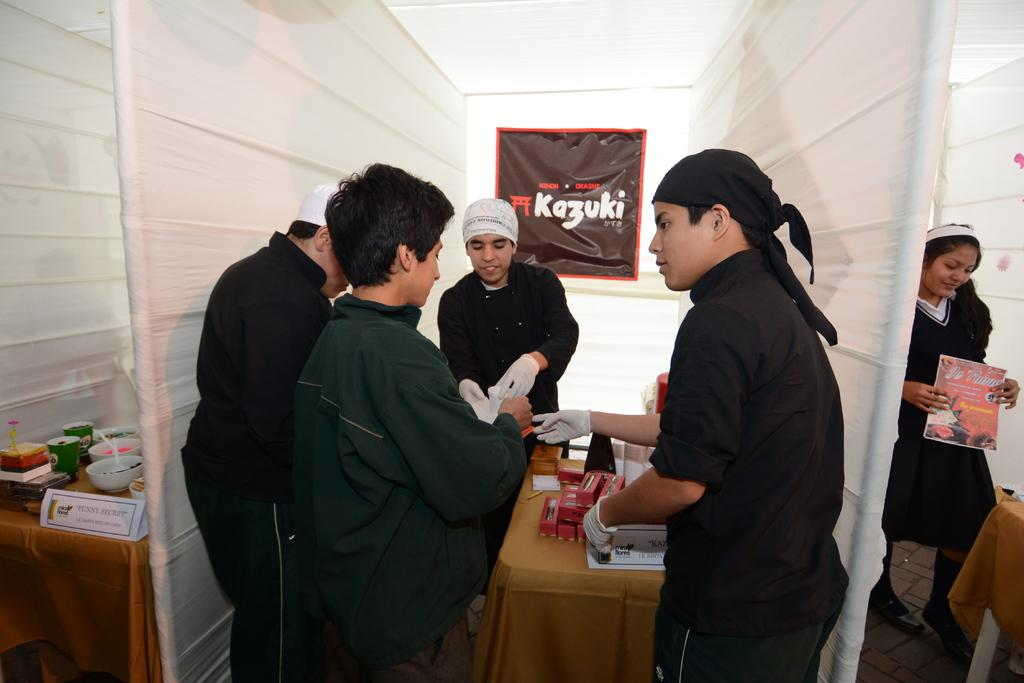Who or what can be seen in the image? There are people in the image. What type of furniture is present in the image? There are tables in the image. What is placed on top of the tables? There are objects on top of the tables. What separates different areas in the image? There are partitions in the image. What can be seen in the background of the image? There is a banner in the background of the image. Who is wearing a crown in the image? There is no one wearing a crown in the image. What type of club is being used in the image? There is no club present in the image. 